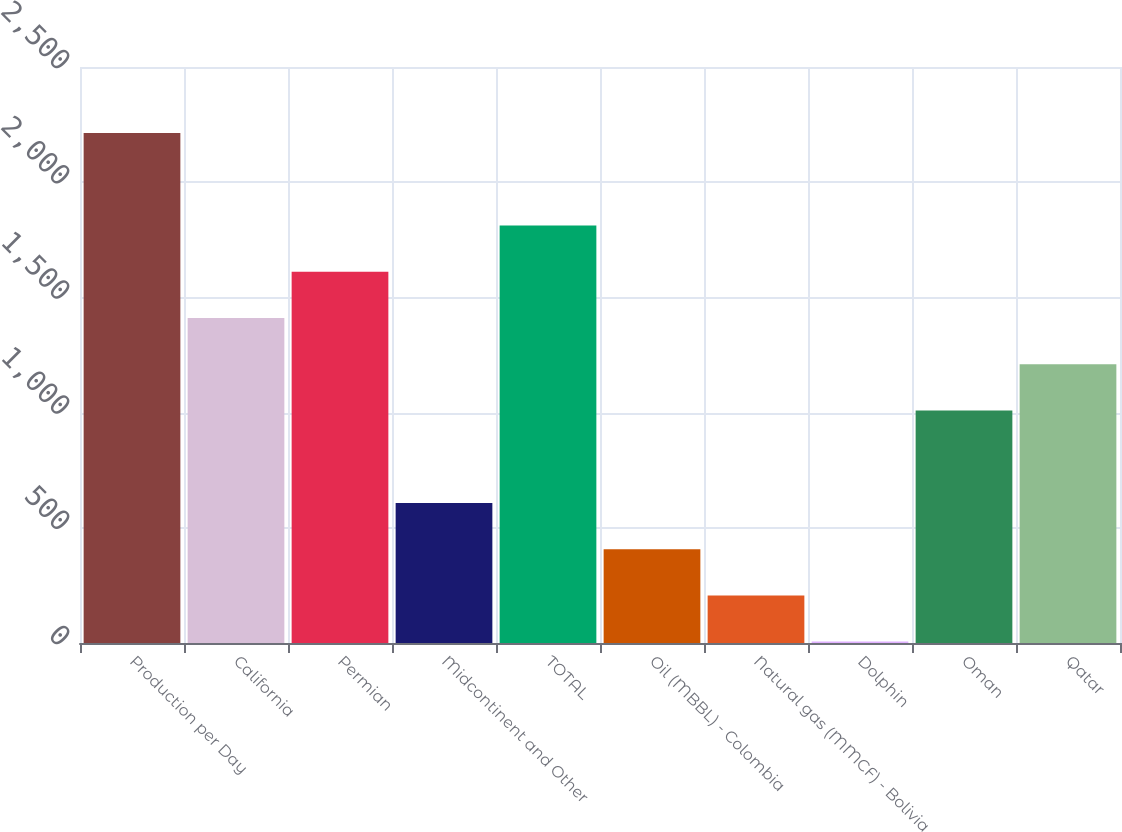<chart> <loc_0><loc_0><loc_500><loc_500><bar_chart><fcel>Production per Day<fcel>California<fcel>Permian<fcel>Midcontinent and Other<fcel>TOTAL<fcel>Oil (MBBL) - Colombia<fcel>Natural gas (MMCF) - Bolivia<fcel>Dolphin<fcel>Oman<fcel>Qatar<nl><fcel>2213.7<fcel>1410.9<fcel>1611.6<fcel>608.1<fcel>1812.3<fcel>407.4<fcel>206.7<fcel>6<fcel>1009.5<fcel>1210.2<nl></chart> 